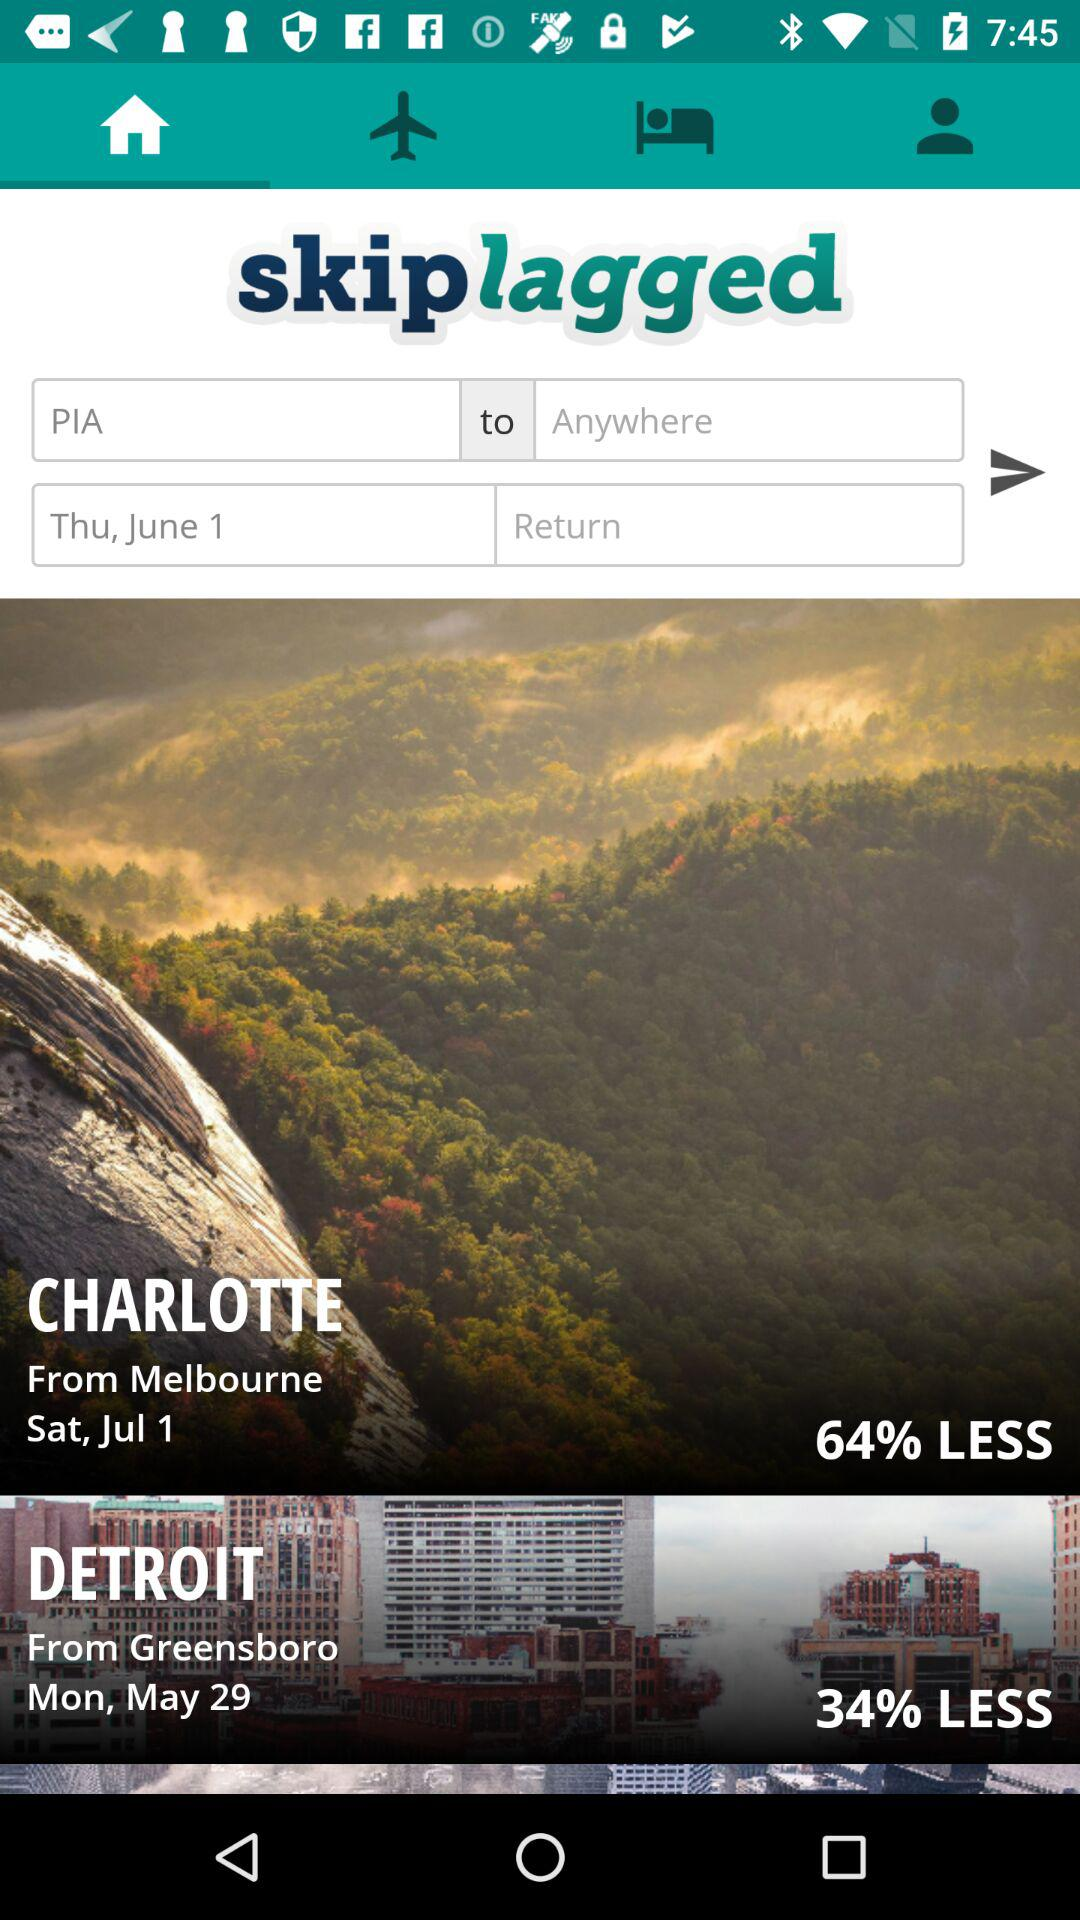What is the name of the application? The name of the application is "skiplagged". 